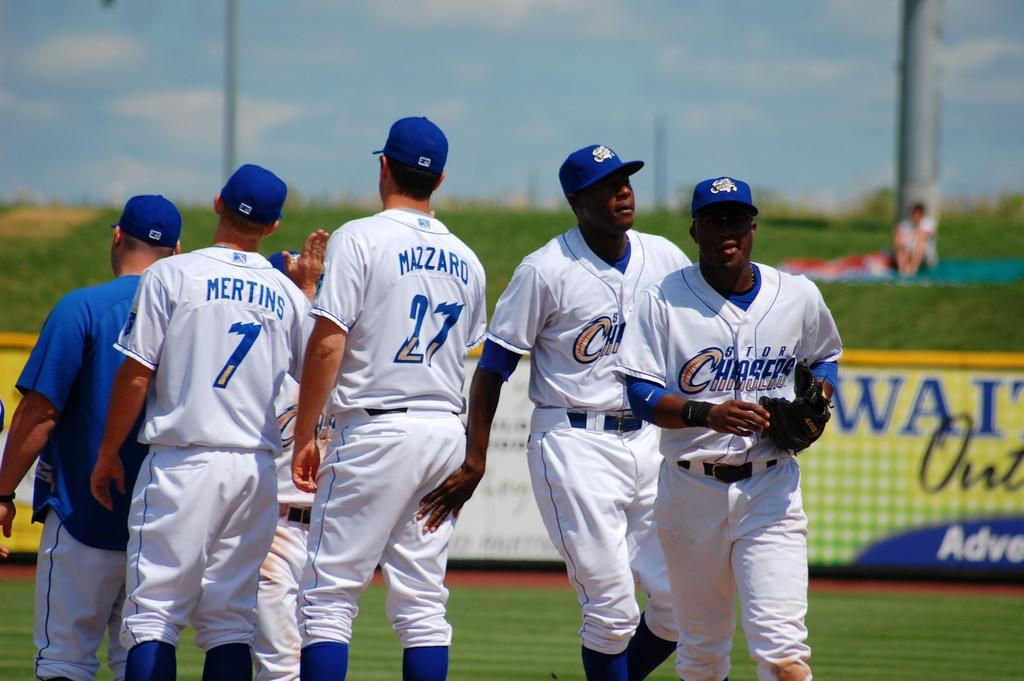<image>
Summarize the visual content of the image. baseball players one with the name Mazzaro on the back 